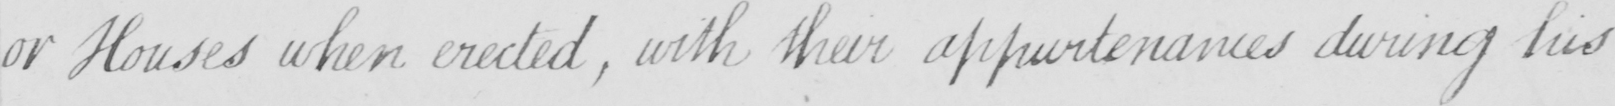Can you tell me what this handwritten text says? or Houses when erected , with their appurtenances during his 